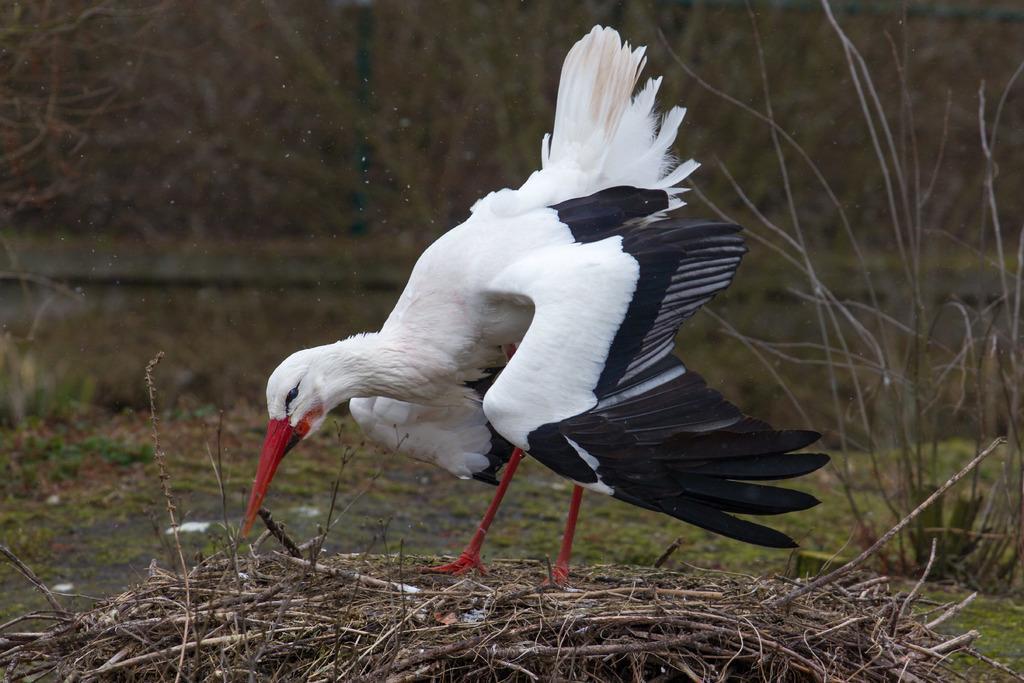How would you summarize this image in a sentence or two? In this image there is a bird standing on the dry sticks, behind the bird there are trees. 